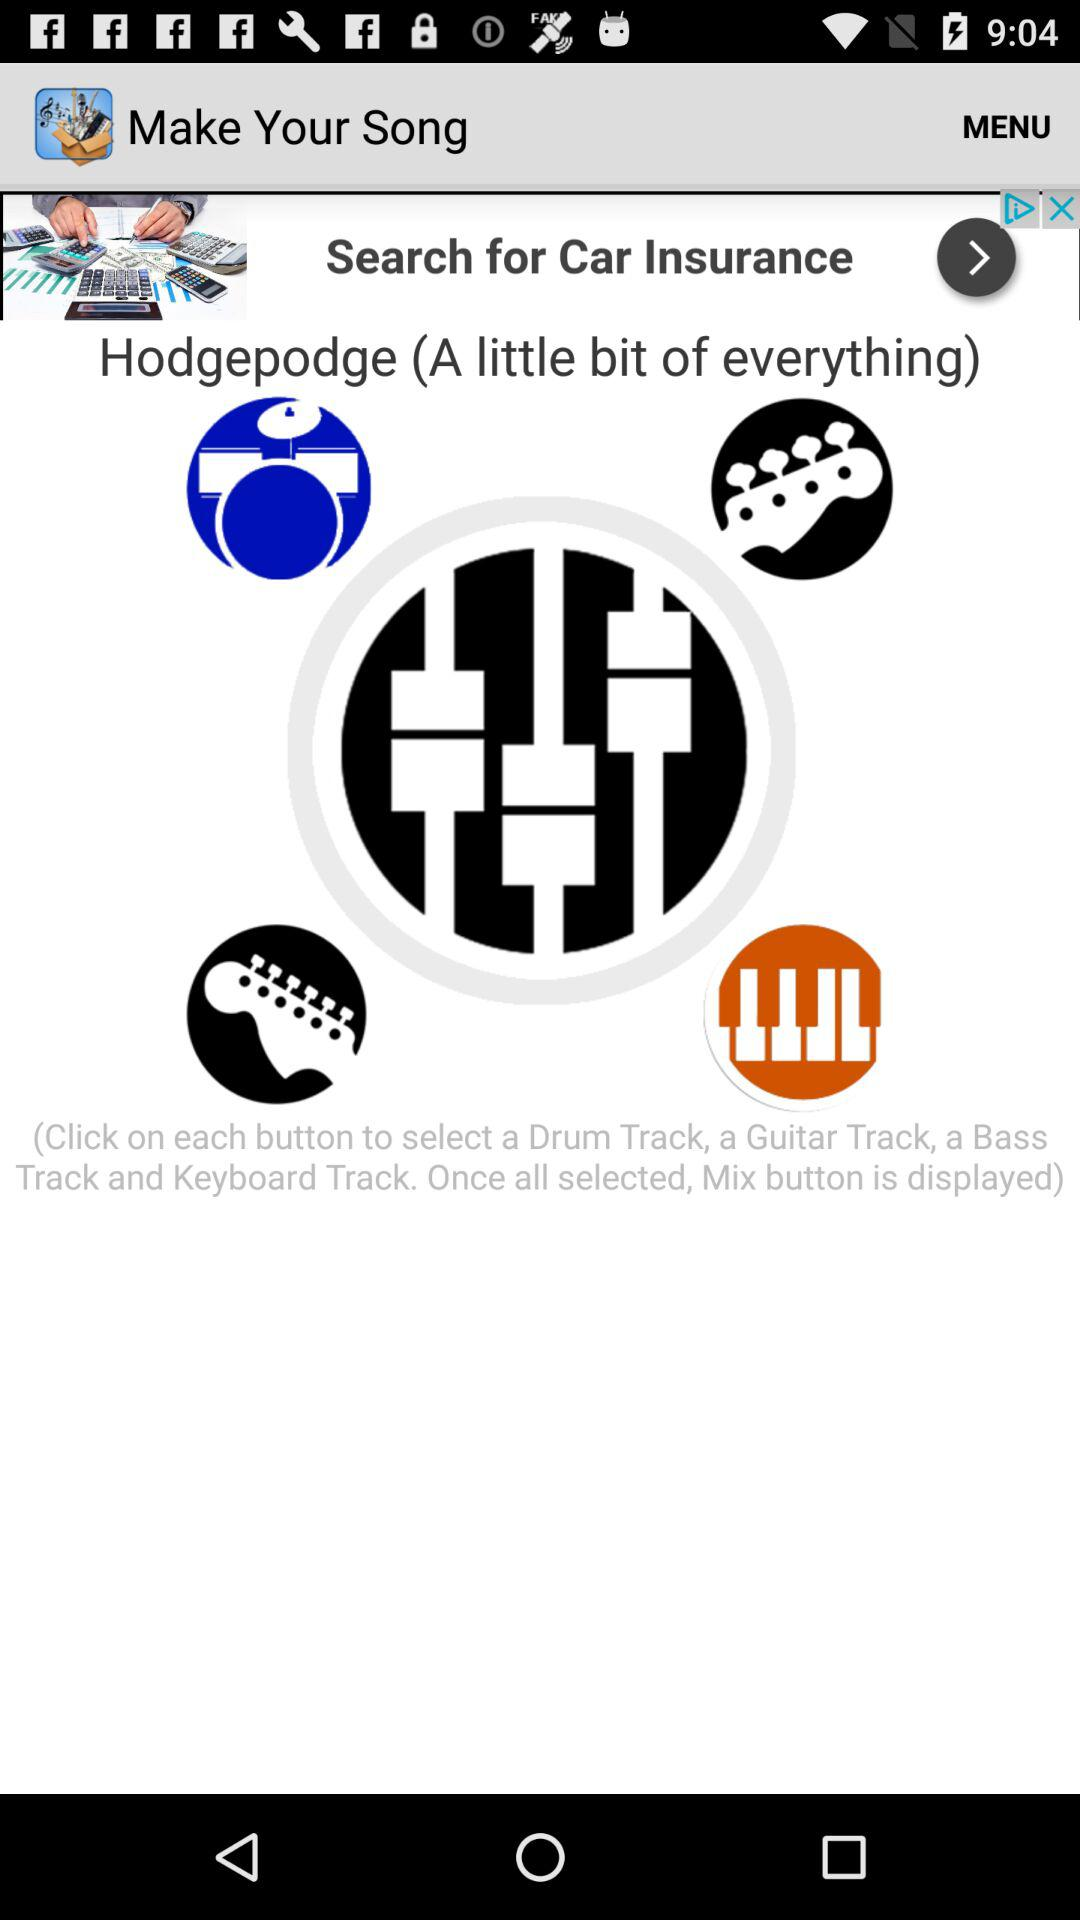What is the name of the song? The name of the song is "Hodgepodge (A little bit of everything)". 